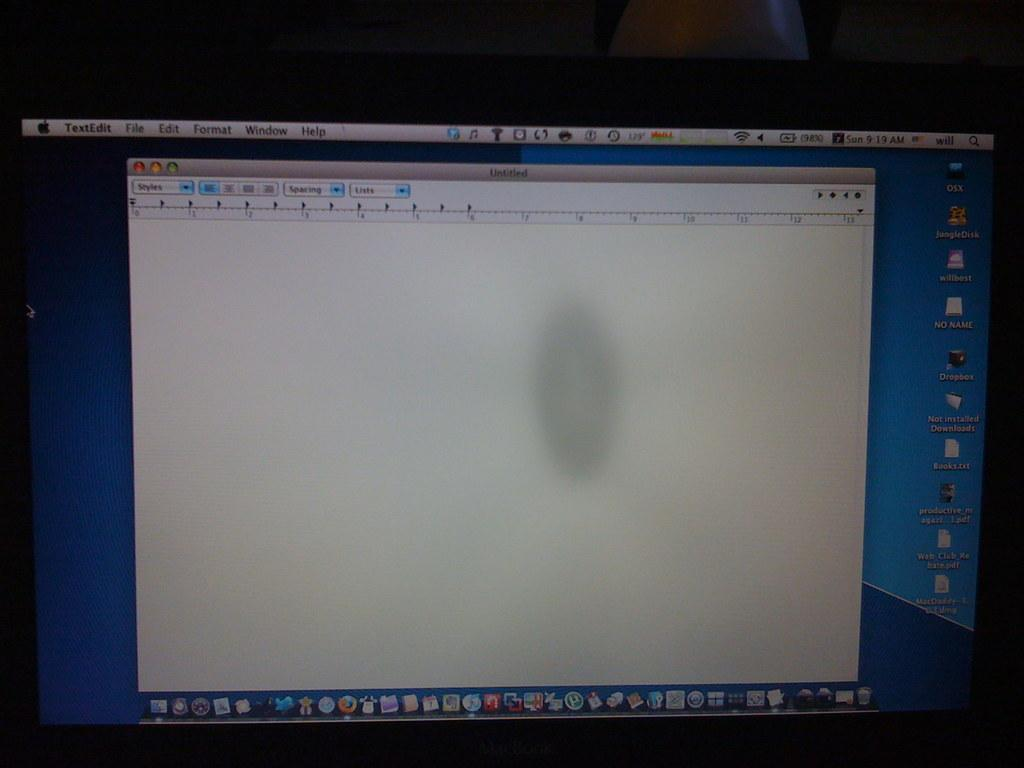<image>
Describe the image concisely. A computer screen displays the day as Sun in the upper right corner. 